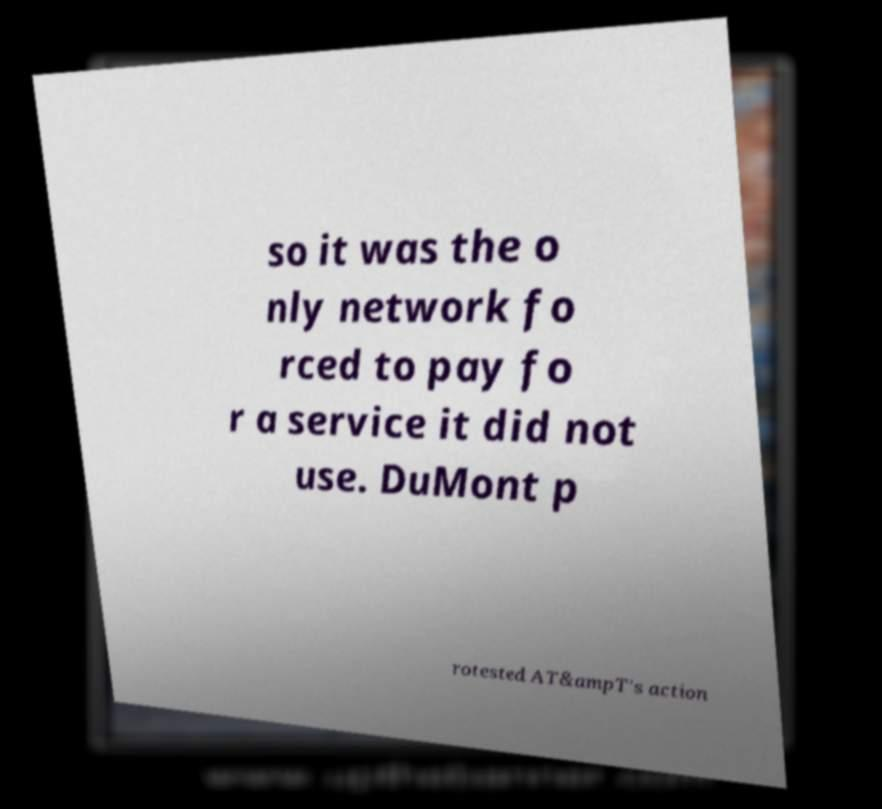Can you accurately transcribe the text from the provided image for me? so it was the o nly network fo rced to pay fo r a service it did not use. DuMont p rotested AT&ampT's action 